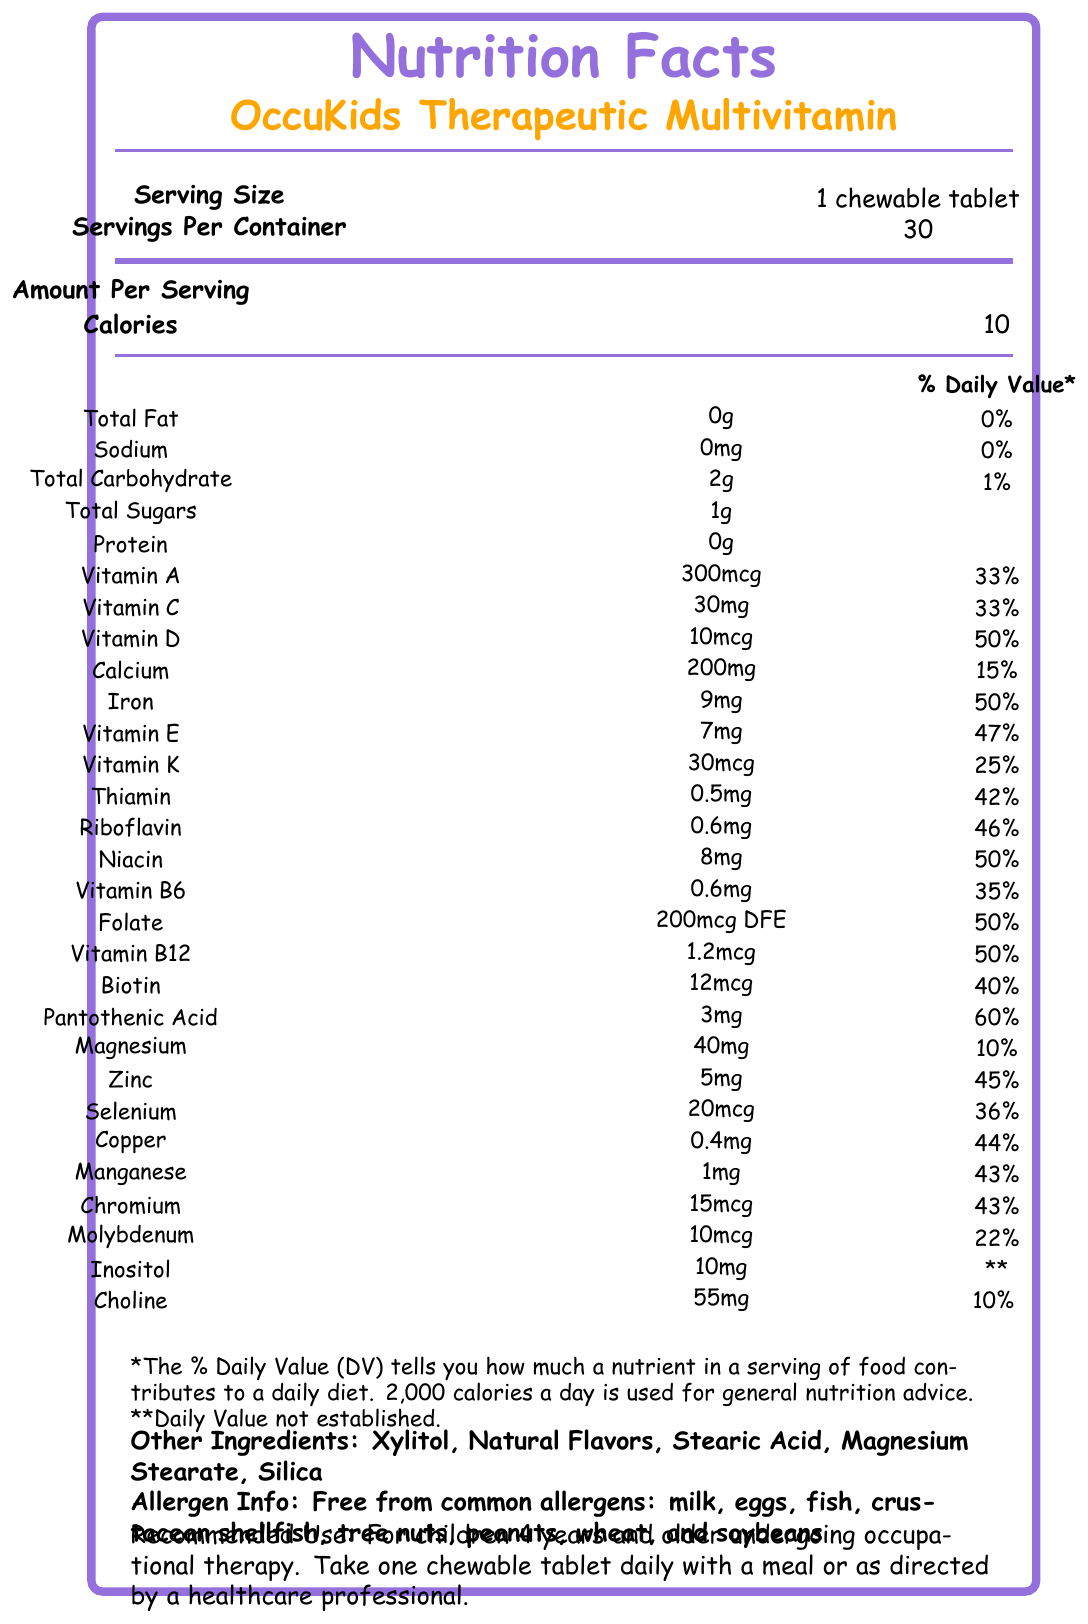who manufactures the OccuKids Therapeutic Multivitamin? The document states "Manufactured by: TherapyNutrition Labs, San Diego, CA 92121."
Answer: TherapyNutrition Labs, San Diego, CA 92121 how many calories are in one serving of the OccuKids Therapeutic Multivitamin? The Amount Per Serving section lists "Calories 10."
Answer: 10 calories what is the serving size for the OccuKids Therapeutic Multivitamin? The Serving Size section specifies "1 chewable tablet."
Answer: 1 chewable tablet how many milligrams of calcium are in each serving? The document shows "Calcium 200mg 15%" under the Amount Per Serving section.
Answer: 200mg what are the three supportive claims made on the nutrition label? The document lists these claims under the section "Supportive Claims."
Answer: Supports healthy sensory processing, Promotes focus and attention, Aids in fine motor skill development does this multivitamin contain any common allergens? The Allergen Info section states "Free from common allergens: milk, eggs, fish, crustacean shellfish, tree nuts, peanuts, wheat, and soybeans."
Answer: No how many servings are there per container? The Servings Per Container section indicates "30."
Answer: 30 servings which vitamins contribute 50% of the daily value? A. Vitamin C & Vitamin B6 B. Vitamin D & Folate C. Vitamin E & Biotin The labels show Vitamin D 50% and Folate 50%.
Answer: B. Vitamin D & Folate what kind of certification does the product have? A. Organic B. Non-GMO C. GMP Certified D. Gluten-Free The Certifications section lists "GMP Certified, Non-GMO, Gluten-Free."
Answer: B. Non-GMO, C. GMP Certified, D. Gluten-Free are children under 4 recommended to use this supplement? The Recommended Use section states, "For children 4 years and older undergoing occupational therapy."
Answer: No what is the main idea of the document? The document provides comprehensive details, including serving size, nutritional content, allergens, usage recommendations, and supportive claims of the OccuKids Therapeutic Multivitamin.
Answer: The main idea of the document is to provide detailed nutrition facts and product-specific information for the OccuKids Therapeutic Multivitamin, a supplement for children undergoing occupational therapy. is the exact amount of each vitamin that contributes over 40% of the daily value listed? Vitamins contributing over 40% of the daily value each have their specific amounts listed in the document.
Answer: Yes how much xylitol is in one serving of the supplement? The document lists "Xylitol" as an ingredient but does not specify the amount.
Answer: Not enough information what are some additional ingredients in the multivitamin? The Other Ingredients section lists these additional ingredients.
Answer: Xylitol, Natural Flavors, Stearic Acid, Magnesium Stearate, Silica which vitamin is present in the highest amount in each serving? The document shows "Vitamin C 30mg 33%," which is the highest weight amongst the vitamins listed.
Answer: Vitamin C what should you do if your child's medical condition is present before using this product? The warning statement advises, "If your child has a medical condition, consult with a healthcare professional before use."
Answer: Consult with a healthcare professional 